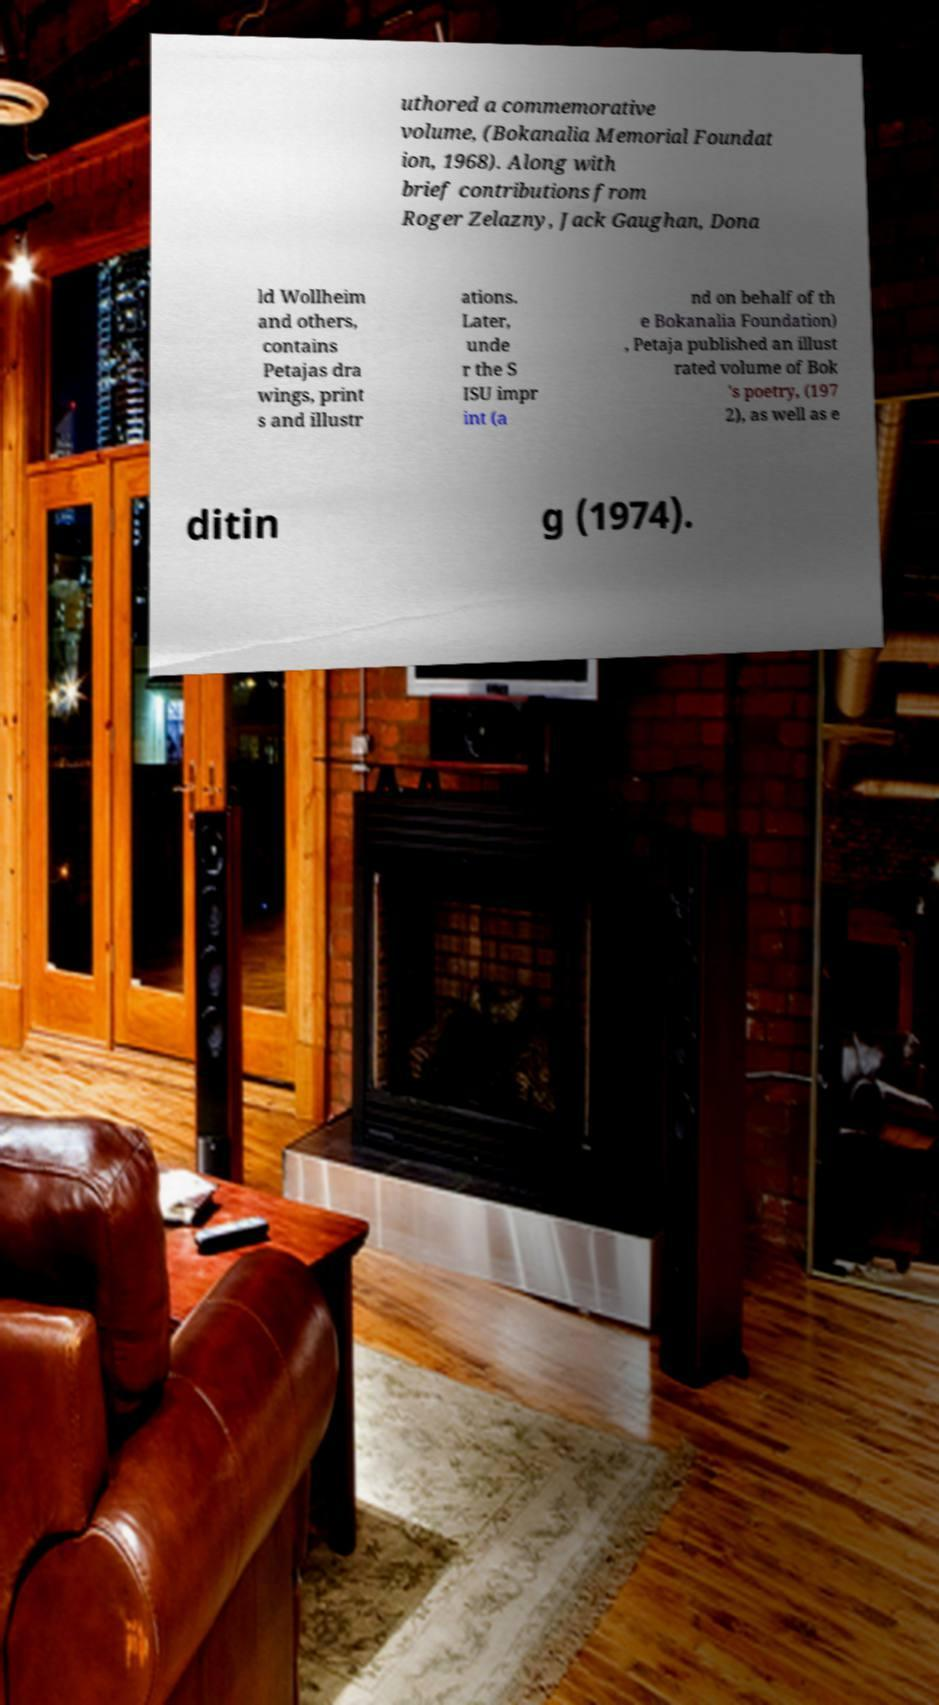Could you extract and type out the text from this image? uthored a commemorative volume, (Bokanalia Memorial Foundat ion, 1968). Along with brief contributions from Roger Zelazny, Jack Gaughan, Dona ld Wollheim and others, contains Petajas dra wings, print s and illustr ations. Later, unde r the S ISU impr int (a nd on behalf of th e Bokanalia Foundation) , Petaja published an illust rated volume of Bok 's poetry, (197 2), as well as e ditin g (1974). 